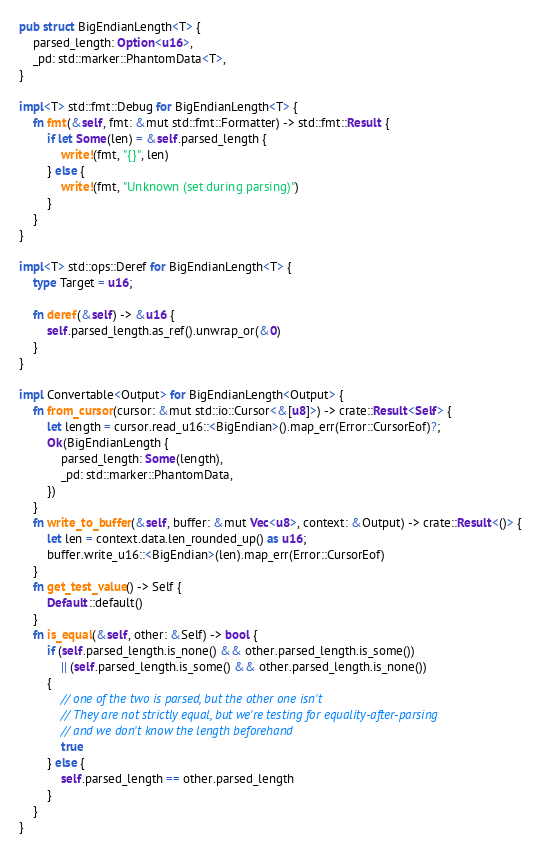<code> <loc_0><loc_0><loc_500><loc_500><_Rust_>pub struct BigEndianLength<T> {
    parsed_length: Option<u16>,
    _pd: std::marker::PhantomData<T>,
}

impl<T> std::fmt::Debug for BigEndianLength<T> {
    fn fmt(&self, fmt: &mut std::fmt::Formatter) -> std::fmt::Result {
        if let Some(len) = &self.parsed_length {
            write!(fmt, "{}", len)
        } else {
            write!(fmt, "Unknown (set during parsing)")
        }
    }
}

impl<T> std::ops::Deref for BigEndianLength<T> {
    type Target = u16;

    fn deref(&self) -> &u16 {
        self.parsed_length.as_ref().unwrap_or(&0)
    }
}

impl Convertable<Output> for BigEndianLength<Output> {
    fn from_cursor(cursor: &mut std::io::Cursor<&[u8]>) -> crate::Result<Self> {
        let length = cursor.read_u16::<BigEndian>().map_err(Error::CursorEof)?;
        Ok(BigEndianLength {
            parsed_length: Some(length),
            _pd: std::marker::PhantomData,
        })
    }
    fn write_to_buffer(&self, buffer: &mut Vec<u8>, context: &Output) -> crate::Result<()> {
        let len = context.data.len_rounded_up() as u16;
        buffer.write_u16::<BigEndian>(len).map_err(Error::CursorEof)
    }
    fn get_test_value() -> Self {
        Default::default()
    }
    fn is_equal(&self, other: &Self) -> bool {
        if (self.parsed_length.is_none() && other.parsed_length.is_some())
            || (self.parsed_length.is_some() && other.parsed_length.is_none())
        {
            // one of the two is parsed, but the other one isn't
            // They are not strictly equal, but we're testing for equality-after-parsing
            // and we don't know the length beforehand
            true
        } else {
            self.parsed_length == other.parsed_length
        }
    }
}
</code> 